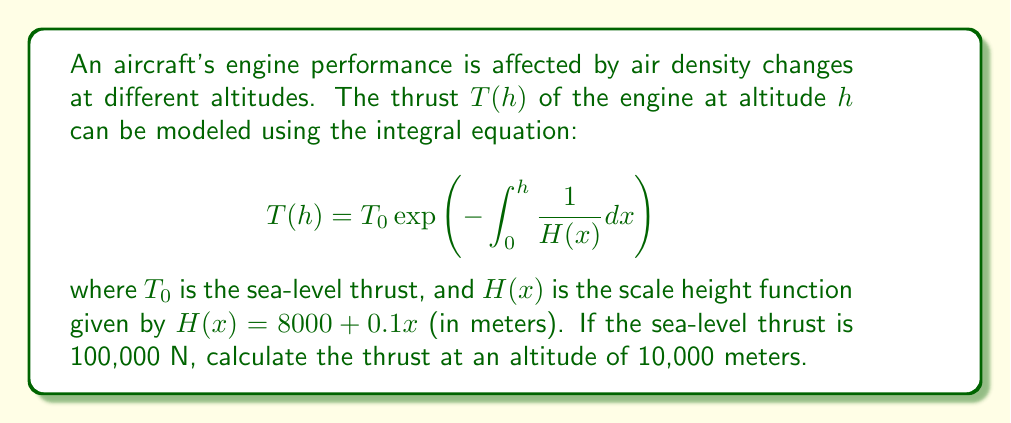What is the answer to this math problem? To solve this problem, we'll follow these steps:

1) First, we need to evaluate the integral inside the exponential function:

   $$\int_0^h \frac{1}{H(x)} dx = \int_0^{10000} \frac{1}{8000 + 0.1x} dx$$

2) This integral can be solved using the substitution method:
   Let $u = 8000 + 0.1x$, then $du = 0.1dx$ or $dx = 10du$

3) Changing the limits of integration:
   When $x = 0$, $u = 8000$
   When $x = 10000$, $u = 9000$

4) The integral becomes:

   $$10\int_{8000}^{9000} \frac{1}{u} du = 10[\ln|u|]_{8000}^{9000} = 10[\ln(9000) - \ln(8000)]$$

5) Evaluating:

   $$10[\ln(9000) - \ln(8000)] = 10\ln\left(\frac{9000}{8000}\right) = 10\ln(1.125) \approx 1.1778$$

6) Now we can calculate the thrust:

   $$T(10000) = 100000 \exp(-1.1778) \approx 30,817 \text{ N}$$
Answer: $30,817 \text{ N}$ 